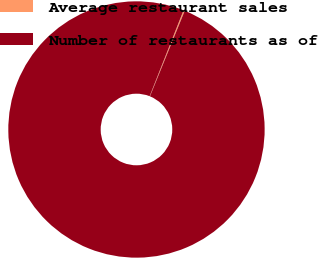Convert chart to OTSL. <chart><loc_0><loc_0><loc_500><loc_500><pie_chart><fcel>Average restaurant sales<fcel>Number of restaurants as of<nl><fcel>0.16%<fcel>99.84%<nl></chart> 